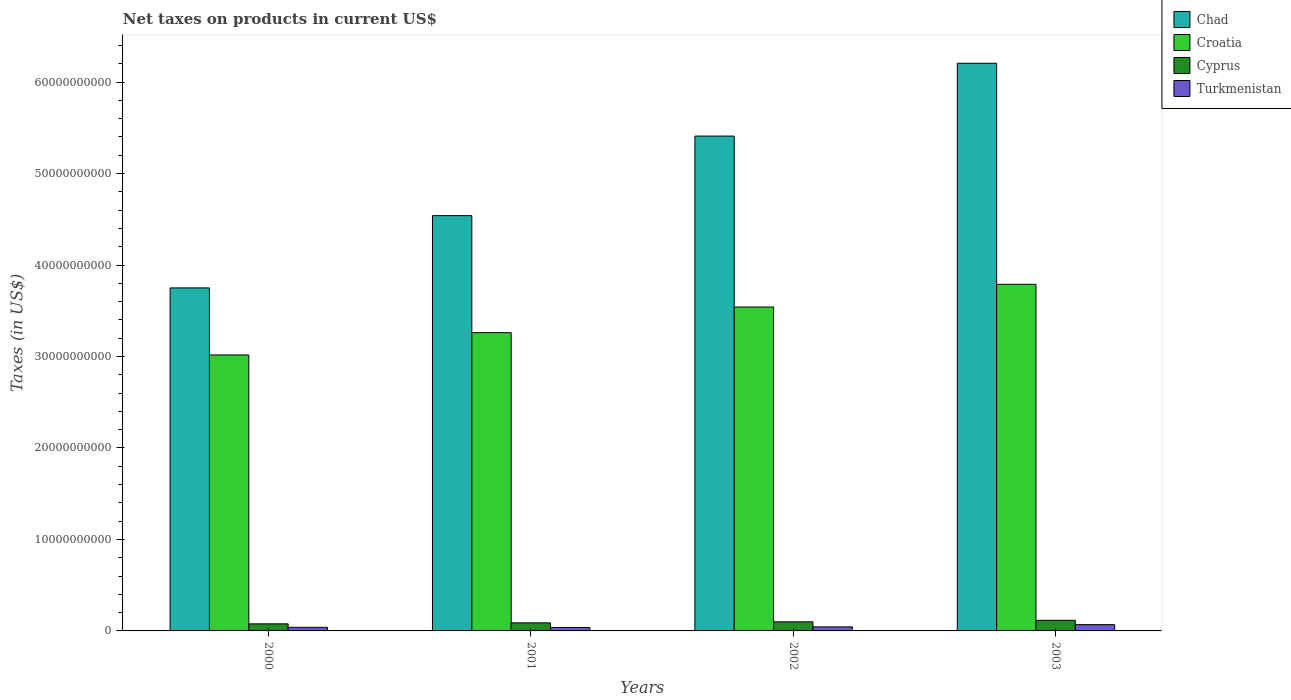How many different coloured bars are there?
Keep it short and to the point. 4. How many groups of bars are there?
Offer a very short reply. 4. How many bars are there on the 4th tick from the right?
Ensure brevity in your answer.  4. What is the label of the 4th group of bars from the left?
Ensure brevity in your answer.  2003. What is the net taxes on products in Cyprus in 2002?
Offer a very short reply. 9.95e+08. Across all years, what is the maximum net taxes on products in Turkmenistan?
Your answer should be very brief. 6.87e+08. Across all years, what is the minimum net taxes on products in Chad?
Keep it short and to the point. 3.75e+1. What is the total net taxes on products in Cyprus in the graph?
Keep it short and to the point. 3.81e+09. What is the difference between the net taxes on products in Croatia in 2000 and that in 2003?
Offer a terse response. -7.72e+09. What is the difference between the net taxes on products in Turkmenistan in 2000 and the net taxes on products in Croatia in 2002?
Your response must be concise. -3.50e+1. What is the average net taxes on products in Croatia per year?
Offer a terse response. 3.40e+1. In the year 2003, what is the difference between the net taxes on products in Cyprus and net taxes on products in Chad?
Your answer should be compact. -6.09e+1. In how many years, is the net taxes on products in Turkmenistan greater than 20000000000 US$?
Offer a terse response. 0. What is the ratio of the net taxes on products in Cyprus in 2000 to that in 2002?
Your response must be concise. 0.78. Is the difference between the net taxes on products in Cyprus in 2000 and 2003 greater than the difference between the net taxes on products in Chad in 2000 and 2003?
Provide a succinct answer. Yes. What is the difference between the highest and the second highest net taxes on products in Turkmenistan?
Offer a terse response. 2.43e+08. What is the difference between the highest and the lowest net taxes on products in Turkmenistan?
Keep it short and to the point. 3.14e+08. In how many years, is the net taxes on products in Croatia greater than the average net taxes on products in Croatia taken over all years?
Provide a short and direct response. 2. What does the 4th bar from the left in 2000 represents?
Keep it short and to the point. Turkmenistan. What does the 4th bar from the right in 2002 represents?
Provide a succinct answer. Chad. How many bars are there?
Offer a terse response. 16. Are the values on the major ticks of Y-axis written in scientific E-notation?
Your response must be concise. No. How many legend labels are there?
Give a very brief answer. 4. How are the legend labels stacked?
Offer a very short reply. Vertical. What is the title of the graph?
Offer a terse response. Net taxes on products in current US$. Does "Pacific island small states" appear as one of the legend labels in the graph?
Keep it short and to the point. No. What is the label or title of the Y-axis?
Your answer should be very brief. Taxes (in US$). What is the Taxes (in US$) in Chad in 2000?
Your answer should be very brief. 3.75e+1. What is the Taxes (in US$) of Croatia in 2000?
Your answer should be very brief. 3.02e+1. What is the Taxes (in US$) in Cyprus in 2000?
Ensure brevity in your answer.  7.73e+08. What is the Taxes (in US$) of Turkmenistan in 2000?
Your answer should be compact. 3.92e+08. What is the Taxes (in US$) in Chad in 2001?
Give a very brief answer. 4.54e+1. What is the Taxes (in US$) of Croatia in 2001?
Keep it short and to the point. 3.26e+1. What is the Taxes (in US$) of Cyprus in 2001?
Provide a succinct answer. 8.80e+08. What is the Taxes (in US$) in Turkmenistan in 2001?
Give a very brief answer. 3.73e+08. What is the Taxes (in US$) in Chad in 2002?
Your answer should be compact. 5.41e+1. What is the Taxes (in US$) in Croatia in 2002?
Provide a short and direct response. 3.54e+1. What is the Taxes (in US$) of Cyprus in 2002?
Provide a succinct answer. 9.95e+08. What is the Taxes (in US$) of Turkmenistan in 2002?
Your answer should be compact. 4.44e+08. What is the Taxes (in US$) of Chad in 2003?
Keep it short and to the point. 6.21e+1. What is the Taxes (in US$) in Croatia in 2003?
Keep it short and to the point. 3.79e+1. What is the Taxes (in US$) in Cyprus in 2003?
Your answer should be very brief. 1.16e+09. What is the Taxes (in US$) in Turkmenistan in 2003?
Offer a very short reply. 6.87e+08. Across all years, what is the maximum Taxes (in US$) in Chad?
Ensure brevity in your answer.  6.21e+1. Across all years, what is the maximum Taxes (in US$) in Croatia?
Your response must be concise. 3.79e+1. Across all years, what is the maximum Taxes (in US$) of Cyprus?
Your answer should be very brief. 1.16e+09. Across all years, what is the maximum Taxes (in US$) of Turkmenistan?
Provide a succinct answer. 6.87e+08. Across all years, what is the minimum Taxes (in US$) in Chad?
Make the answer very short. 3.75e+1. Across all years, what is the minimum Taxes (in US$) in Croatia?
Provide a short and direct response. 3.02e+1. Across all years, what is the minimum Taxes (in US$) in Cyprus?
Provide a succinct answer. 7.73e+08. Across all years, what is the minimum Taxes (in US$) in Turkmenistan?
Your response must be concise. 3.73e+08. What is the total Taxes (in US$) of Chad in the graph?
Ensure brevity in your answer.  1.99e+11. What is the total Taxes (in US$) in Croatia in the graph?
Offer a very short reply. 1.36e+11. What is the total Taxes (in US$) of Cyprus in the graph?
Your response must be concise. 3.81e+09. What is the total Taxes (in US$) in Turkmenistan in the graph?
Offer a terse response. 1.90e+09. What is the difference between the Taxes (in US$) in Chad in 2000 and that in 2001?
Provide a short and direct response. -7.90e+09. What is the difference between the Taxes (in US$) of Croatia in 2000 and that in 2001?
Provide a succinct answer. -2.44e+09. What is the difference between the Taxes (in US$) in Cyprus in 2000 and that in 2001?
Offer a very short reply. -1.08e+08. What is the difference between the Taxes (in US$) in Turkmenistan in 2000 and that in 2001?
Offer a very short reply. 1.94e+07. What is the difference between the Taxes (in US$) of Chad in 2000 and that in 2002?
Your response must be concise. -1.66e+1. What is the difference between the Taxes (in US$) in Croatia in 2000 and that in 2002?
Your answer should be very brief. -5.24e+09. What is the difference between the Taxes (in US$) of Cyprus in 2000 and that in 2002?
Your answer should be very brief. -2.22e+08. What is the difference between the Taxes (in US$) in Turkmenistan in 2000 and that in 2002?
Ensure brevity in your answer.  -5.20e+07. What is the difference between the Taxes (in US$) of Chad in 2000 and that in 2003?
Ensure brevity in your answer.  -2.46e+1. What is the difference between the Taxes (in US$) in Croatia in 2000 and that in 2003?
Provide a short and direct response. -7.72e+09. What is the difference between the Taxes (in US$) in Cyprus in 2000 and that in 2003?
Offer a very short reply. -3.89e+08. What is the difference between the Taxes (in US$) of Turkmenistan in 2000 and that in 2003?
Your answer should be very brief. -2.95e+08. What is the difference between the Taxes (in US$) in Chad in 2001 and that in 2002?
Your answer should be compact. -8.70e+09. What is the difference between the Taxes (in US$) of Croatia in 2001 and that in 2002?
Your response must be concise. -2.80e+09. What is the difference between the Taxes (in US$) of Cyprus in 2001 and that in 2002?
Give a very brief answer. -1.14e+08. What is the difference between the Taxes (in US$) in Turkmenistan in 2001 and that in 2002?
Your answer should be very brief. -7.14e+07. What is the difference between the Taxes (in US$) in Chad in 2001 and that in 2003?
Make the answer very short. -1.67e+1. What is the difference between the Taxes (in US$) of Croatia in 2001 and that in 2003?
Offer a terse response. -5.28e+09. What is the difference between the Taxes (in US$) in Cyprus in 2001 and that in 2003?
Keep it short and to the point. -2.82e+08. What is the difference between the Taxes (in US$) in Turkmenistan in 2001 and that in 2003?
Your answer should be compact. -3.14e+08. What is the difference between the Taxes (in US$) in Chad in 2002 and that in 2003?
Offer a very short reply. -7.96e+09. What is the difference between the Taxes (in US$) of Croatia in 2002 and that in 2003?
Provide a short and direct response. -2.48e+09. What is the difference between the Taxes (in US$) of Cyprus in 2002 and that in 2003?
Your answer should be very brief. -1.68e+08. What is the difference between the Taxes (in US$) of Turkmenistan in 2002 and that in 2003?
Ensure brevity in your answer.  -2.43e+08. What is the difference between the Taxes (in US$) of Chad in 2000 and the Taxes (in US$) of Croatia in 2001?
Provide a succinct answer. 4.89e+09. What is the difference between the Taxes (in US$) in Chad in 2000 and the Taxes (in US$) in Cyprus in 2001?
Your answer should be very brief. 3.66e+1. What is the difference between the Taxes (in US$) in Chad in 2000 and the Taxes (in US$) in Turkmenistan in 2001?
Make the answer very short. 3.71e+1. What is the difference between the Taxes (in US$) of Croatia in 2000 and the Taxes (in US$) of Cyprus in 2001?
Keep it short and to the point. 2.93e+1. What is the difference between the Taxes (in US$) of Croatia in 2000 and the Taxes (in US$) of Turkmenistan in 2001?
Offer a terse response. 2.98e+1. What is the difference between the Taxes (in US$) of Cyprus in 2000 and the Taxes (in US$) of Turkmenistan in 2001?
Your answer should be compact. 4.00e+08. What is the difference between the Taxes (in US$) of Chad in 2000 and the Taxes (in US$) of Croatia in 2002?
Make the answer very short. 2.09e+09. What is the difference between the Taxes (in US$) of Chad in 2000 and the Taxes (in US$) of Cyprus in 2002?
Offer a terse response. 3.65e+1. What is the difference between the Taxes (in US$) in Chad in 2000 and the Taxes (in US$) in Turkmenistan in 2002?
Offer a terse response. 3.71e+1. What is the difference between the Taxes (in US$) in Croatia in 2000 and the Taxes (in US$) in Cyprus in 2002?
Keep it short and to the point. 2.92e+1. What is the difference between the Taxes (in US$) of Croatia in 2000 and the Taxes (in US$) of Turkmenistan in 2002?
Provide a succinct answer. 2.97e+1. What is the difference between the Taxes (in US$) of Cyprus in 2000 and the Taxes (in US$) of Turkmenistan in 2002?
Offer a terse response. 3.29e+08. What is the difference between the Taxes (in US$) in Chad in 2000 and the Taxes (in US$) in Croatia in 2003?
Make the answer very short. -3.92e+08. What is the difference between the Taxes (in US$) of Chad in 2000 and the Taxes (in US$) of Cyprus in 2003?
Give a very brief answer. 3.63e+1. What is the difference between the Taxes (in US$) of Chad in 2000 and the Taxes (in US$) of Turkmenistan in 2003?
Ensure brevity in your answer.  3.68e+1. What is the difference between the Taxes (in US$) in Croatia in 2000 and the Taxes (in US$) in Cyprus in 2003?
Offer a very short reply. 2.90e+1. What is the difference between the Taxes (in US$) in Croatia in 2000 and the Taxes (in US$) in Turkmenistan in 2003?
Ensure brevity in your answer.  2.95e+1. What is the difference between the Taxes (in US$) in Cyprus in 2000 and the Taxes (in US$) in Turkmenistan in 2003?
Offer a very short reply. 8.60e+07. What is the difference between the Taxes (in US$) of Chad in 2001 and the Taxes (in US$) of Croatia in 2002?
Give a very brief answer. 9.99e+09. What is the difference between the Taxes (in US$) in Chad in 2001 and the Taxes (in US$) in Cyprus in 2002?
Give a very brief answer. 4.44e+1. What is the difference between the Taxes (in US$) of Chad in 2001 and the Taxes (in US$) of Turkmenistan in 2002?
Offer a very short reply. 4.50e+1. What is the difference between the Taxes (in US$) in Croatia in 2001 and the Taxes (in US$) in Cyprus in 2002?
Your answer should be very brief. 3.16e+1. What is the difference between the Taxes (in US$) in Croatia in 2001 and the Taxes (in US$) in Turkmenistan in 2002?
Provide a short and direct response. 3.22e+1. What is the difference between the Taxes (in US$) in Cyprus in 2001 and the Taxes (in US$) in Turkmenistan in 2002?
Your response must be concise. 4.36e+08. What is the difference between the Taxes (in US$) of Chad in 2001 and the Taxes (in US$) of Croatia in 2003?
Offer a very short reply. 7.51e+09. What is the difference between the Taxes (in US$) in Chad in 2001 and the Taxes (in US$) in Cyprus in 2003?
Provide a short and direct response. 4.42e+1. What is the difference between the Taxes (in US$) in Chad in 2001 and the Taxes (in US$) in Turkmenistan in 2003?
Provide a short and direct response. 4.47e+1. What is the difference between the Taxes (in US$) in Croatia in 2001 and the Taxes (in US$) in Cyprus in 2003?
Your response must be concise. 3.14e+1. What is the difference between the Taxes (in US$) in Croatia in 2001 and the Taxes (in US$) in Turkmenistan in 2003?
Ensure brevity in your answer.  3.19e+1. What is the difference between the Taxes (in US$) of Cyprus in 2001 and the Taxes (in US$) of Turkmenistan in 2003?
Provide a succinct answer. 1.94e+08. What is the difference between the Taxes (in US$) of Chad in 2002 and the Taxes (in US$) of Croatia in 2003?
Make the answer very short. 1.62e+1. What is the difference between the Taxes (in US$) of Chad in 2002 and the Taxes (in US$) of Cyprus in 2003?
Offer a very short reply. 5.29e+1. What is the difference between the Taxes (in US$) of Chad in 2002 and the Taxes (in US$) of Turkmenistan in 2003?
Give a very brief answer. 5.34e+1. What is the difference between the Taxes (in US$) of Croatia in 2002 and the Taxes (in US$) of Cyprus in 2003?
Your answer should be very brief. 3.43e+1. What is the difference between the Taxes (in US$) in Croatia in 2002 and the Taxes (in US$) in Turkmenistan in 2003?
Your answer should be compact. 3.47e+1. What is the difference between the Taxes (in US$) in Cyprus in 2002 and the Taxes (in US$) in Turkmenistan in 2003?
Provide a succinct answer. 3.08e+08. What is the average Taxes (in US$) in Chad per year?
Your answer should be very brief. 4.98e+1. What is the average Taxes (in US$) in Croatia per year?
Offer a terse response. 3.40e+1. What is the average Taxes (in US$) in Cyprus per year?
Ensure brevity in your answer.  9.52e+08. What is the average Taxes (in US$) in Turkmenistan per year?
Provide a succinct answer. 4.74e+08. In the year 2000, what is the difference between the Taxes (in US$) of Chad and Taxes (in US$) of Croatia?
Your answer should be compact. 7.33e+09. In the year 2000, what is the difference between the Taxes (in US$) in Chad and Taxes (in US$) in Cyprus?
Your response must be concise. 3.67e+1. In the year 2000, what is the difference between the Taxes (in US$) in Chad and Taxes (in US$) in Turkmenistan?
Your answer should be very brief. 3.71e+1. In the year 2000, what is the difference between the Taxes (in US$) in Croatia and Taxes (in US$) in Cyprus?
Provide a succinct answer. 2.94e+1. In the year 2000, what is the difference between the Taxes (in US$) in Croatia and Taxes (in US$) in Turkmenistan?
Provide a short and direct response. 2.98e+1. In the year 2000, what is the difference between the Taxes (in US$) of Cyprus and Taxes (in US$) of Turkmenistan?
Your answer should be very brief. 3.81e+08. In the year 2001, what is the difference between the Taxes (in US$) in Chad and Taxes (in US$) in Croatia?
Your answer should be compact. 1.28e+1. In the year 2001, what is the difference between the Taxes (in US$) of Chad and Taxes (in US$) of Cyprus?
Provide a short and direct response. 4.45e+1. In the year 2001, what is the difference between the Taxes (in US$) of Chad and Taxes (in US$) of Turkmenistan?
Offer a very short reply. 4.50e+1. In the year 2001, what is the difference between the Taxes (in US$) of Croatia and Taxes (in US$) of Cyprus?
Your answer should be very brief. 3.17e+1. In the year 2001, what is the difference between the Taxes (in US$) of Croatia and Taxes (in US$) of Turkmenistan?
Offer a terse response. 3.22e+1. In the year 2001, what is the difference between the Taxes (in US$) in Cyprus and Taxes (in US$) in Turkmenistan?
Your answer should be compact. 5.08e+08. In the year 2002, what is the difference between the Taxes (in US$) in Chad and Taxes (in US$) in Croatia?
Provide a succinct answer. 1.87e+1. In the year 2002, what is the difference between the Taxes (in US$) of Chad and Taxes (in US$) of Cyprus?
Offer a very short reply. 5.31e+1. In the year 2002, what is the difference between the Taxes (in US$) in Chad and Taxes (in US$) in Turkmenistan?
Your response must be concise. 5.37e+1. In the year 2002, what is the difference between the Taxes (in US$) of Croatia and Taxes (in US$) of Cyprus?
Give a very brief answer. 3.44e+1. In the year 2002, what is the difference between the Taxes (in US$) in Croatia and Taxes (in US$) in Turkmenistan?
Provide a succinct answer. 3.50e+1. In the year 2002, what is the difference between the Taxes (in US$) of Cyprus and Taxes (in US$) of Turkmenistan?
Give a very brief answer. 5.51e+08. In the year 2003, what is the difference between the Taxes (in US$) in Chad and Taxes (in US$) in Croatia?
Offer a terse response. 2.42e+1. In the year 2003, what is the difference between the Taxes (in US$) in Chad and Taxes (in US$) in Cyprus?
Ensure brevity in your answer.  6.09e+1. In the year 2003, what is the difference between the Taxes (in US$) in Chad and Taxes (in US$) in Turkmenistan?
Provide a short and direct response. 6.14e+1. In the year 2003, what is the difference between the Taxes (in US$) of Croatia and Taxes (in US$) of Cyprus?
Provide a short and direct response. 3.67e+1. In the year 2003, what is the difference between the Taxes (in US$) of Croatia and Taxes (in US$) of Turkmenistan?
Provide a short and direct response. 3.72e+1. In the year 2003, what is the difference between the Taxes (in US$) of Cyprus and Taxes (in US$) of Turkmenistan?
Your answer should be very brief. 4.75e+08. What is the ratio of the Taxes (in US$) in Chad in 2000 to that in 2001?
Give a very brief answer. 0.83. What is the ratio of the Taxes (in US$) in Croatia in 2000 to that in 2001?
Provide a short and direct response. 0.93. What is the ratio of the Taxes (in US$) in Cyprus in 2000 to that in 2001?
Make the answer very short. 0.88. What is the ratio of the Taxes (in US$) of Turkmenistan in 2000 to that in 2001?
Make the answer very short. 1.05. What is the ratio of the Taxes (in US$) of Chad in 2000 to that in 2002?
Keep it short and to the point. 0.69. What is the ratio of the Taxes (in US$) in Croatia in 2000 to that in 2002?
Give a very brief answer. 0.85. What is the ratio of the Taxes (in US$) of Cyprus in 2000 to that in 2002?
Keep it short and to the point. 0.78. What is the ratio of the Taxes (in US$) of Turkmenistan in 2000 to that in 2002?
Your answer should be compact. 0.88. What is the ratio of the Taxes (in US$) in Chad in 2000 to that in 2003?
Your answer should be compact. 0.6. What is the ratio of the Taxes (in US$) of Croatia in 2000 to that in 2003?
Provide a succinct answer. 0.8. What is the ratio of the Taxes (in US$) of Cyprus in 2000 to that in 2003?
Make the answer very short. 0.66. What is the ratio of the Taxes (in US$) of Turkmenistan in 2000 to that in 2003?
Make the answer very short. 0.57. What is the ratio of the Taxes (in US$) in Chad in 2001 to that in 2002?
Your answer should be compact. 0.84. What is the ratio of the Taxes (in US$) in Croatia in 2001 to that in 2002?
Provide a succinct answer. 0.92. What is the ratio of the Taxes (in US$) of Cyprus in 2001 to that in 2002?
Your answer should be compact. 0.89. What is the ratio of the Taxes (in US$) of Turkmenistan in 2001 to that in 2002?
Your answer should be very brief. 0.84. What is the ratio of the Taxes (in US$) of Chad in 2001 to that in 2003?
Offer a very short reply. 0.73. What is the ratio of the Taxes (in US$) in Croatia in 2001 to that in 2003?
Your response must be concise. 0.86. What is the ratio of the Taxes (in US$) of Cyprus in 2001 to that in 2003?
Keep it short and to the point. 0.76. What is the ratio of the Taxes (in US$) in Turkmenistan in 2001 to that in 2003?
Your answer should be compact. 0.54. What is the ratio of the Taxes (in US$) in Chad in 2002 to that in 2003?
Provide a succinct answer. 0.87. What is the ratio of the Taxes (in US$) of Croatia in 2002 to that in 2003?
Provide a short and direct response. 0.93. What is the ratio of the Taxes (in US$) of Cyprus in 2002 to that in 2003?
Ensure brevity in your answer.  0.86. What is the ratio of the Taxes (in US$) of Turkmenistan in 2002 to that in 2003?
Offer a terse response. 0.65. What is the difference between the highest and the second highest Taxes (in US$) of Chad?
Keep it short and to the point. 7.96e+09. What is the difference between the highest and the second highest Taxes (in US$) in Croatia?
Your response must be concise. 2.48e+09. What is the difference between the highest and the second highest Taxes (in US$) in Cyprus?
Your answer should be very brief. 1.68e+08. What is the difference between the highest and the second highest Taxes (in US$) in Turkmenistan?
Your answer should be compact. 2.43e+08. What is the difference between the highest and the lowest Taxes (in US$) of Chad?
Make the answer very short. 2.46e+1. What is the difference between the highest and the lowest Taxes (in US$) of Croatia?
Your answer should be very brief. 7.72e+09. What is the difference between the highest and the lowest Taxes (in US$) in Cyprus?
Offer a very short reply. 3.89e+08. What is the difference between the highest and the lowest Taxes (in US$) in Turkmenistan?
Your answer should be very brief. 3.14e+08. 